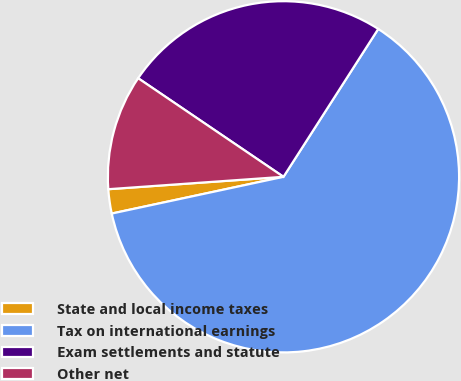Convert chart to OTSL. <chart><loc_0><loc_0><loc_500><loc_500><pie_chart><fcel>State and local income taxes<fcel>Tax on international earnings<fcel>Exam settlements and statute<fcel>Other net<nl><fcel>2.23%<fcel>62.57%<fcel>24.58%<fcel>10.61%<nl></chart> 